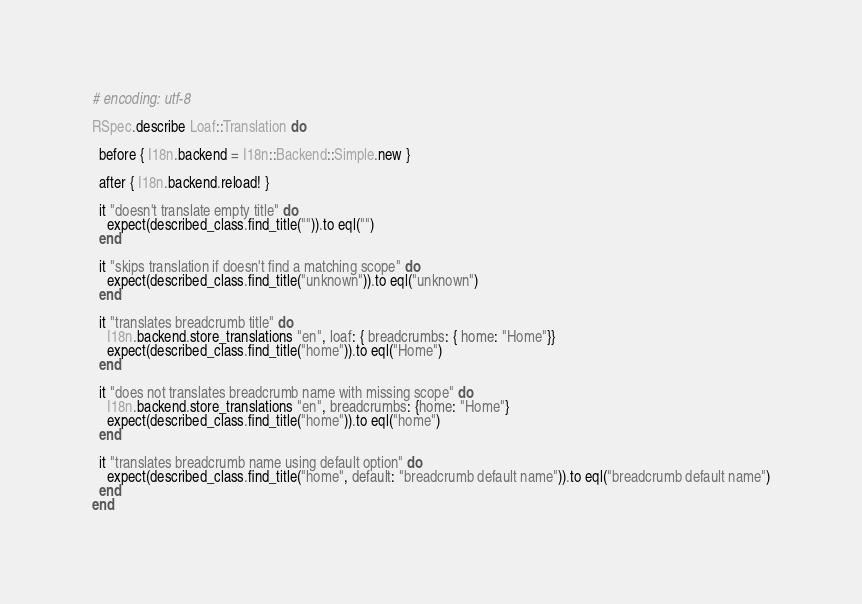Convert code to text. <code><loc_0><loc_0><loc_500><loc_500><_Ruby_># encoding: utf-8

RSpec.describe Loaf::Translation do

  before { I18n.backend = I18n::Backend::Simple.new }

  after { I18n.backend.reload! }

  it "doesn't translate empty title" do
    expect(described_class.find_title("")).to eql("")
  end

  it "skips translation if doesn't find a matching scope" do
    expect(described_class.find_title("unknown")).to eql("unknown")
  end

  it "translates breadcrumb title" do
    I18n.backend.store_translations "en", loaf: { breadcrumbs: { home: "Home"}}
    expect(described_class.find_title("home")).to eql("Home")
  end

  it "does not translates breadcrumb name with missing scope" do
    I18n.backend.store_translations "en", breadcrumbs: {home: "Home"}
    expect(described_class.find_title("home")).to eql("home")
  end

  it "translates breadcrumb name using default option" do
    expect(described_class.find_title("home", default: "breadcrumb default name")).to eql("breadcrumb default name")
  end
end
</code> 